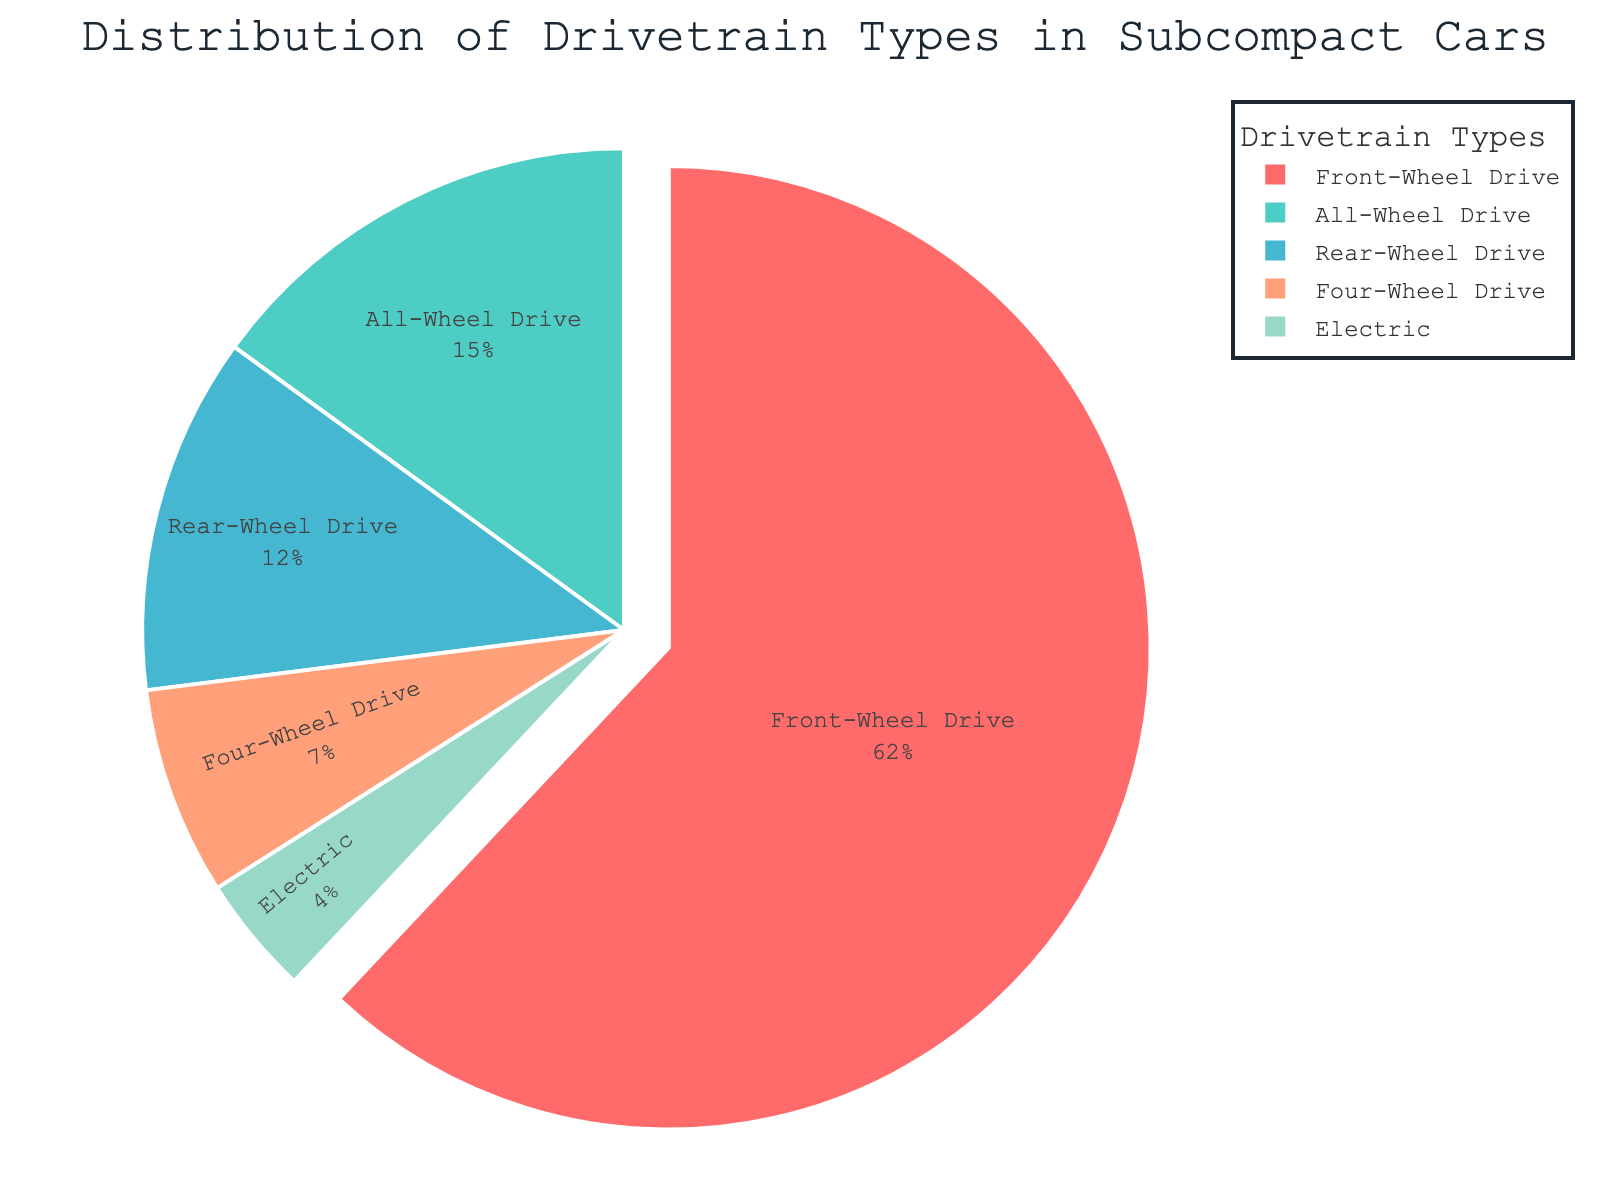Which drivetrain type has the highest percentage? By looking at the figure, the largest slice represents the Front-Wheel Drive with 62%.
Answer: Front-Wheel Drive What is the total percentage accounted for by all types except Front-Wheel Drive? Summing up the percentages of All-Wheel Drive, Rear-Wheel Drive, Four-Wheel Drive, and Electric: 15% + 12% + 7% + 4% = 38%.
Answer: 38% How many drivetrain types make up less than 10% of the distribution? By examining the sizes of slices: Four-Wheel Drive (7%) and Electric (4%) both make up less than 10%.
Answer: 2 Which drivetrain type has the smallest percentage, and what is it? The smallest slice is colored green representing Electric drivetrain with 4%.
Answer: Electric, 4% By which percentage does Front-Wheel Drive exceed All-Wheel Drive? Subtracting the percentage of All-Wheel Drive from that of Front-Wheel Drive: 62% - 15% = 47%.
Answer: 47% What is the combined percentage for Rear-Wheel Drive and All-Wheel Drive? Adding the percentages of Rear-Wheel Drive and All-Wheel Drive: 12% + 15% = 27%.
Answer: 27% Is any drivetrain type exactly twice another one? Comparing slices: The Rear-Wheel Drive (12%) is exactly twice that of Electric (4%).
Answer: No Which drivetrain type is represented by a red slice? Observing the colors of the slices, the red one represents Front-Wheel Drive.
Answer: Front-Wheel Drive What percentage of the distribution is accounted for by four or more types? Front-Wheel Drive, All-Wheel Drive, Rear-Wheel Drive, and Four-Wheel Drive collectively sum to 62% + 15% + 12% + 7% = 96%.
Answer: 96% How much larger in percentage is the Front-Wheel Drive slice compared to the Electric slice? Subtracting the percentage of Electric from the percentage of Front-Wheel Drive: 62% - 4% = 58%.
Answer: 58% 